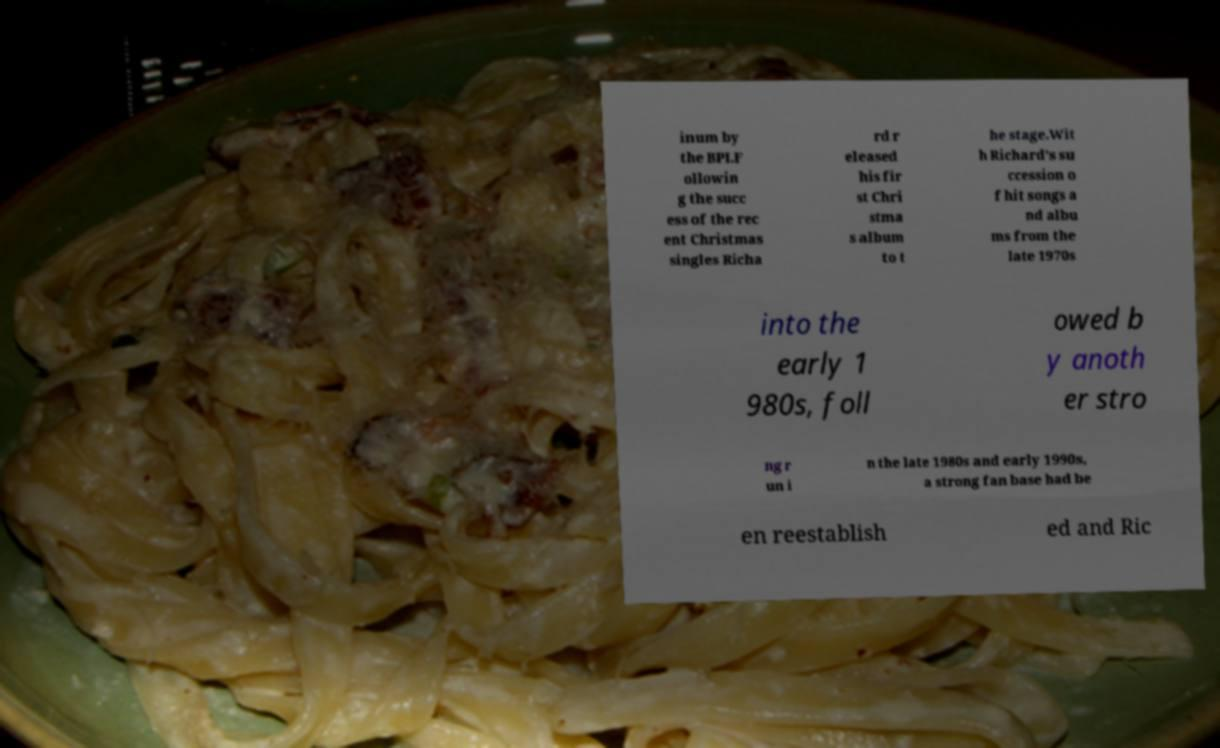Could you extract and type out the text from this image? inum by the BPI.F ollowin g the succ ess of the rec ent Christmas singles Richa rd r eleased his fir st Chri stma s album to t he stage.Wit h Richard's su ccession o f hit songs a nd albu ms from the late 1970s into the early 1 980s, foll owed b y anoth er stro ng r un i n the late 1980s and early 1990s, a strong fan base had be en reestablish ed and Ric 